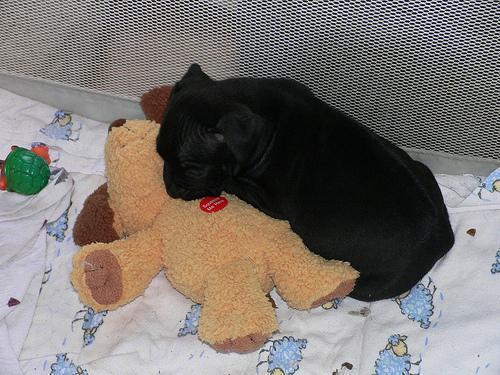How many blue dogs in the photo?
Give a very brief answer. 0. 